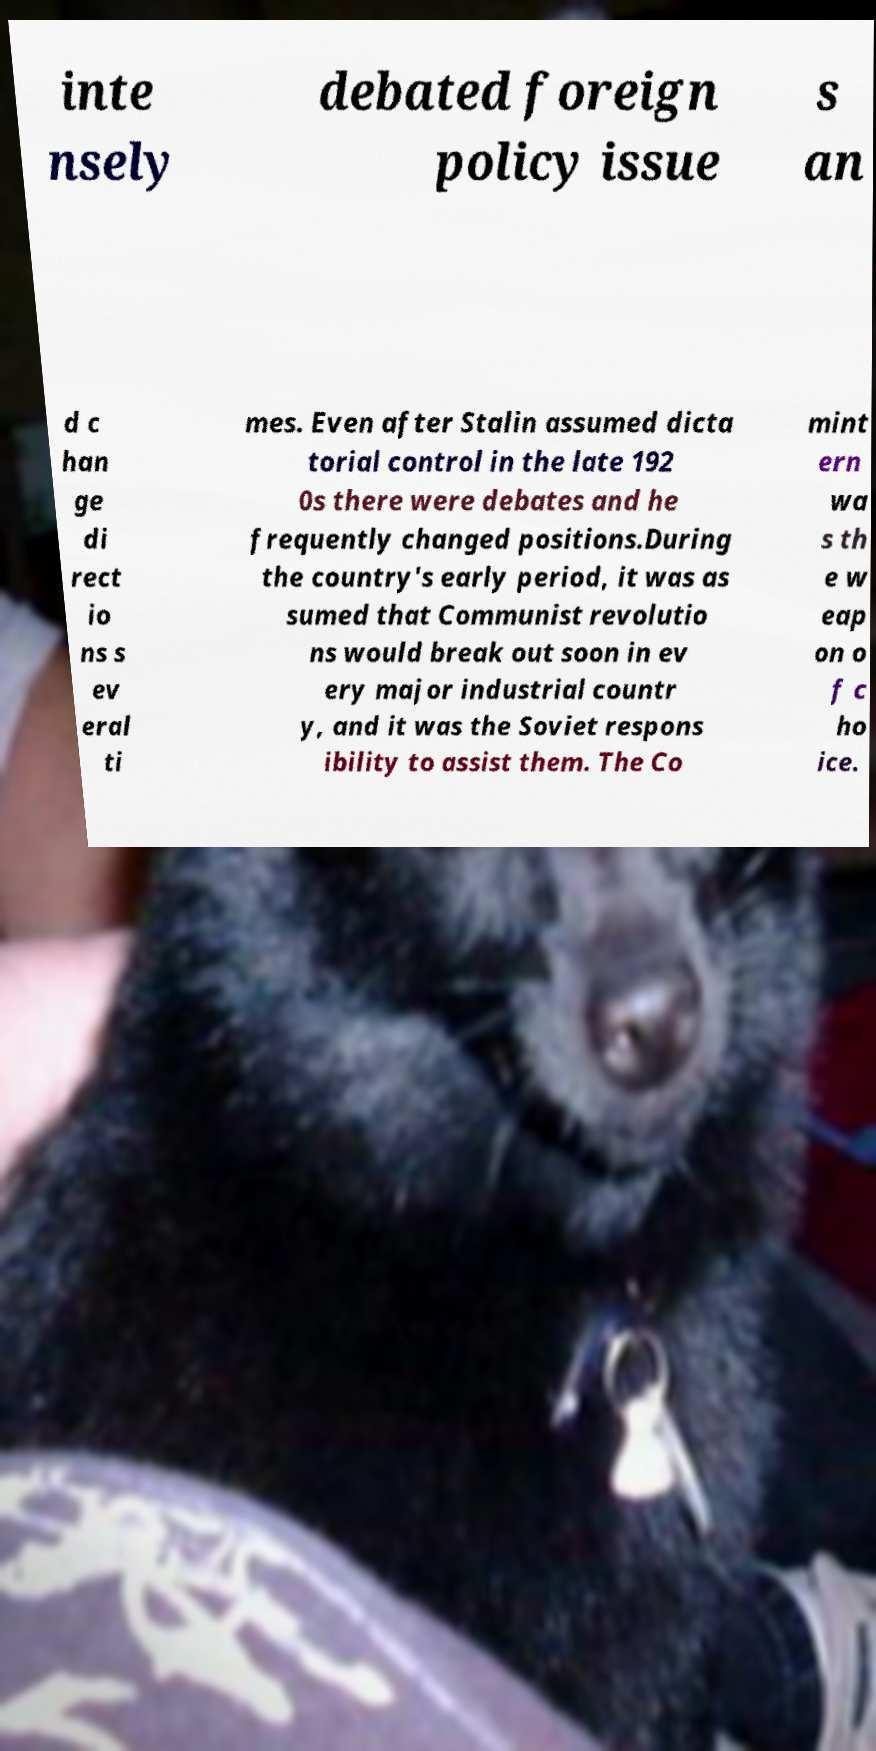For documentation purposes, I need the text within this image transcribed. Could you provide that? inte nsely debated foreign policy issue s an d c han ge di rect io ns s ev eral ti mes. Even after Stalin assumed dicta torial control in the late 192 0s there were debates and he frequently changed positions.During the country's early period, it was as sumed that Communist revolutio ns would break out soon in ev ery major industrial countr y, and it was the Soviet respons ibility to assist them. The Co mint ern wa s th e w eap on o f c ho ice. 